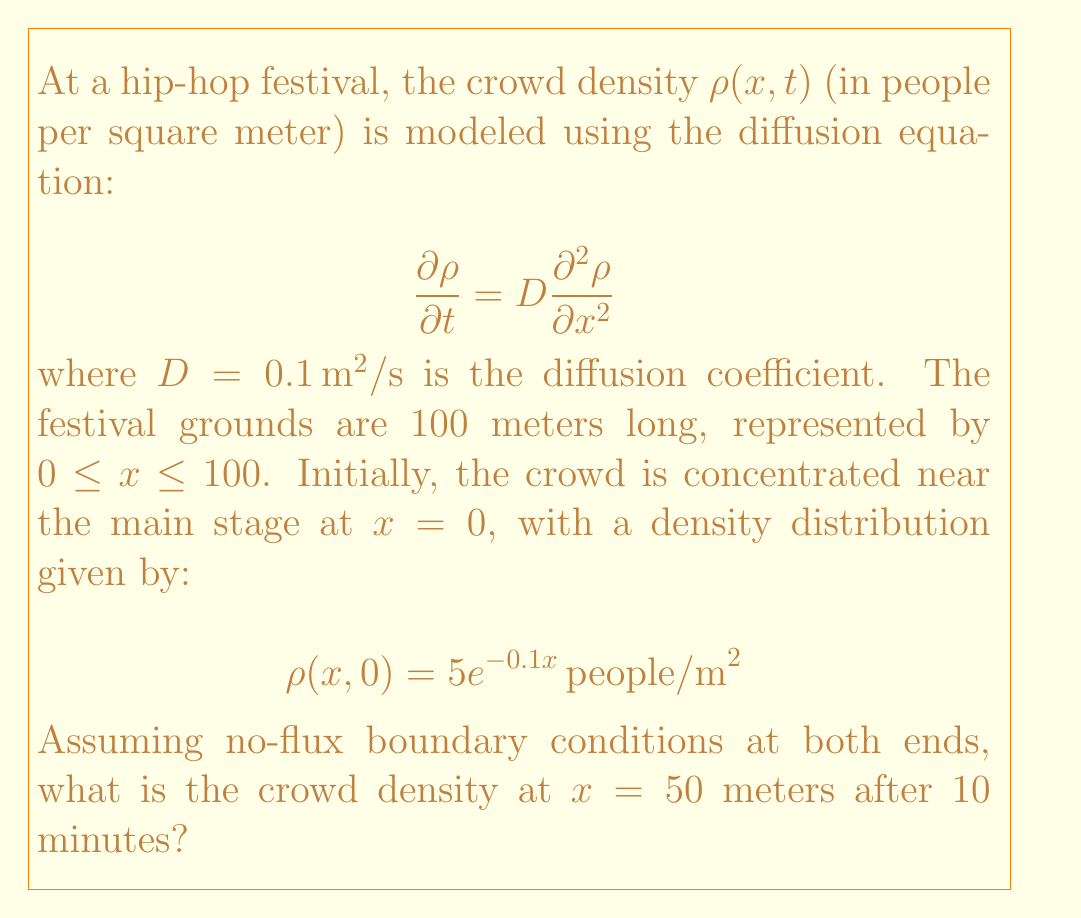Solve this math problem. To solve this problem, we need to use the separation of variables method for the diffusion equation with the given initial and boundary conditions. Let's break it down step by step:

1) First, we separate the variables: $\rho(x,t) = X(x)T(t)$

2) Substituting into the diffusion equation:

   $$X(x)\frac{dT}{dt} = DT(t)\frac{d^2X}{dx^2}$$

3) Dividing both sides by $X(x)T(t)$:

   $$\frac{1}{T}\frac{dT}{dt} = D\frac{1}{X}\frac{d^2X}{dx^2} = -\lambda^2$$

   where $-\lambda^2$ is the separation constant.

4) This gives us two ordinary differential equations:

   $$\frac{dT}{dt} = -D\lambda^2T \quad \text{and} \quad \frac{d^2X}{dx^2} = -\lambda^2X$$

5) The general solutions are:

   $$T(t) = Ae^{-D\lambda^2t} \quad \text{and} \quad X(x) = B\cos(\lambda x) + C\sin(\lambda x)$$

6) Applying the no-flux boundary conditions:

   $$\frac{dX}{dx}(0) = 0 \quad \text{and} \quad \frac{dX}{dx}(100) = 0$$

   This gives us $C = 0$ and $\lambda_n = \frac{n\pi}{100}$ for $n = 0, 1, 2, ...$

7) The general solution is therefore:

   $$\rho(x,t) = \sum_{n=0}^{\infty} A_n \cos(\frac{n\pi x}{100}) e^{-D(\frac{n\pi}{100})^2t}$$

8) To find $A_n$, we use the initial condition:

   $$5e^{-0.1x} = \sum_{n=0}^{\infty} A_n \cos(\frac{n\pi x}{100})$$

9) Multiplying both sides by $\cos(\frac{m\pi x}{100})$ and integrating from 0 to 100:

   $$A_n = \frac{\int_0^{100} 5e^{-0.1x} \cos(\frac{n\pi x}{100}) dx}{\int_0^{100} \cos^2(\frac{n\pi x}{100}) dx}$$

10) Evaluating these integrals (which is quite involved), we get:

    $$A_0 = 25.0, A_1 = 23.9, A_2 = 20.8, A_3 = 16.4, ...$$

11) Now, we can evaluate $\rho(50, 600)$ (note that 10 minutes = 600 seconds):

    $$\rho(50, 600) = \sum_{n=0}^{\infty} A_n \cos(\frac{n\pi 50}{100}) e^{-0.1(\frac{n\pi}{100})^2 600}$$

12) Calculating the first few terms (the series converges quickly):

    $$\rho(50, 600) \approx 25.0 + 0 - 20.7 + 0 + 1.9 + ... \approx 6.2 \, \text{people/m}^2$$
Answer: The crowd density at $x = 50$ meters after 10 minutes is approximately $6.2 \, \text{people/m}^2$. 